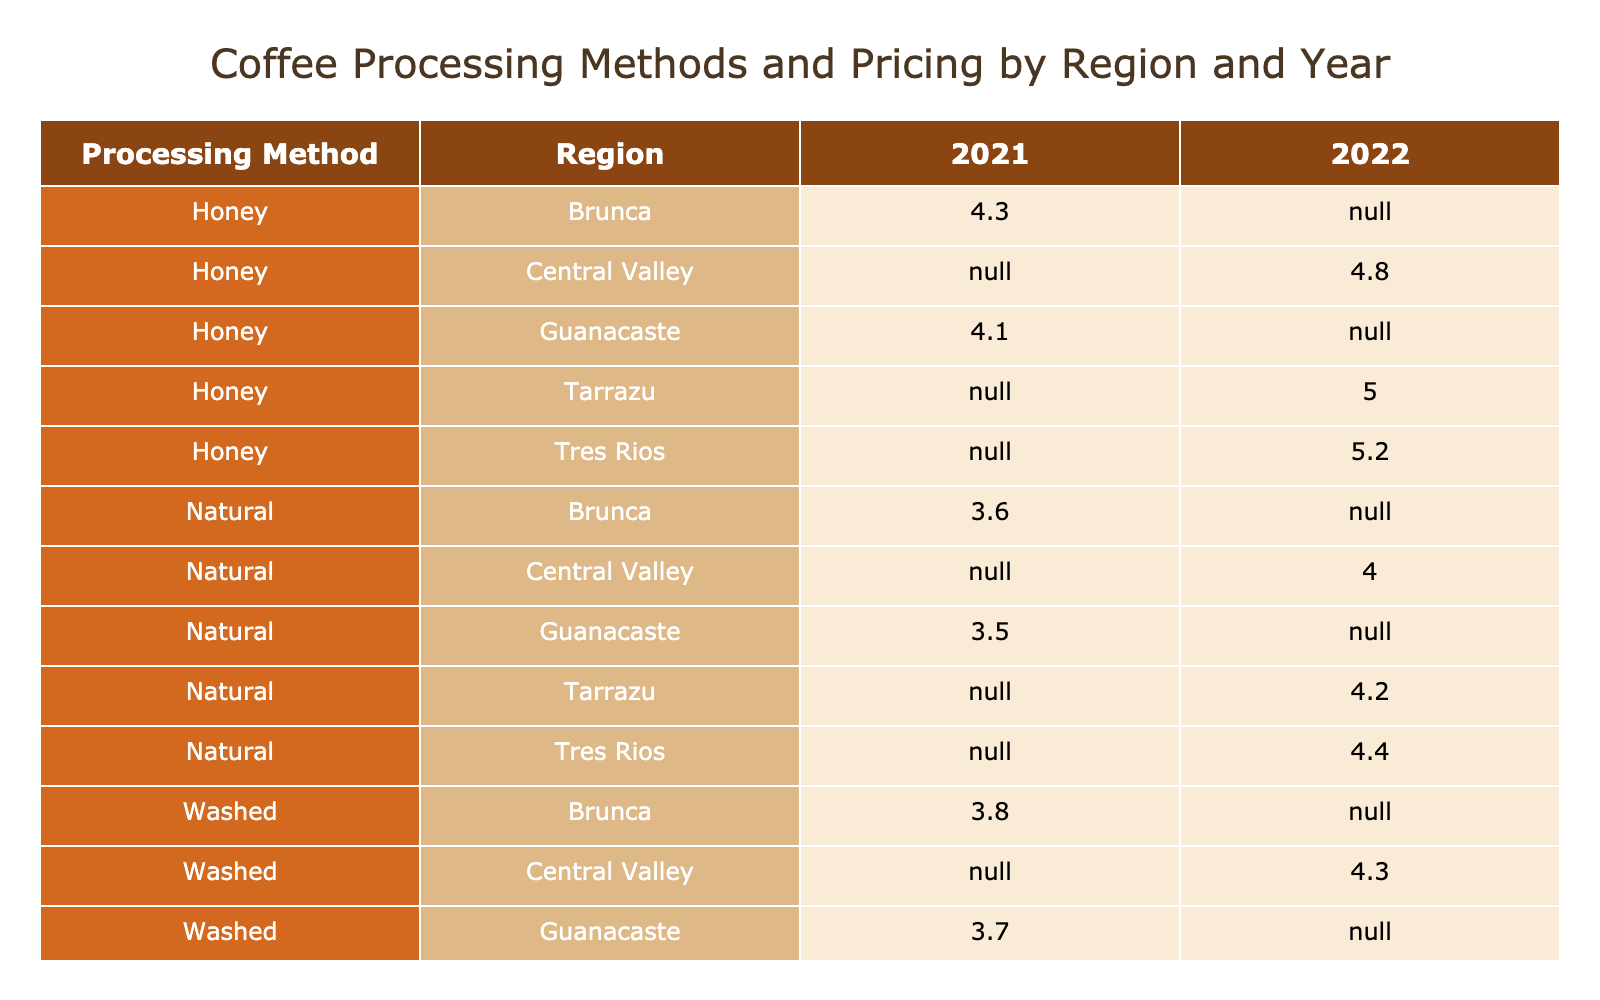What is the price per kg of honey coffee from Tarrazu in 2022? The table shows the price per kg for honey coffee in the Tarrazu region for the harvest year 2022. Looking at the respective cell, it indicates that the price is 5.00.
Answer: 5.00 Which processing method in Brunca had the highest price per kg in 2021? By examining the prices per kg for each processing method in Brunca for the year 2021, we find washed coffee has a price of 3.80, natural coffee is 3.60, and honey coffee is 4.30. Honey coffee has the highest price.
Answer: Honey What is the average price per kg for washed coffee across all regions in 2022? The prices for washed coffee in 2022 are 4.50 (Tarrazu), 4.30 (Central Valley), and 4.70 (Tres Rios). To calculate the average, add these prices (4.50 + 4.30 + 4.70) = 13.50 and then divide by 3 (the number of regions), which results in an average price of 4.50.
Answer: 4.50 Is the price per kg of natural coffee from Guanacaste higher than from Brunca in 2021? Checking the table for natural coffee prices: Guanacaste has a price of 3.50 while Brunca has a price of 3.60. Since 3.50 is not higher than 3.60, the answer is no.
Answer: No What is the total production volume of honey coffee across all regions in 2022? The production volumes for honey coffee in 2022 are 2000 kg (Tarrazu), 2200 kg (Central Valley), and 1900 kg (Tres Rios). Adding these figures gives us a total production volume of 2000 + 2200 + 1900 = 6100 kg.
Answer: 6100 kg Which region produced the most coffee in 2022, and what was the total production volume? For the year 2022, we check the production volumes by region: Tarrazu (5000 kg washed + 3500 kg natural + 2000 kg honey = 10500 kg), Central Valley (5500 kg washed + 4000 kg natural + 2200 kg honey = 11700 kg), and Tres Rios (4800 kg washed + 3200 kg natural + 1900 kg honey = 9900 kg). Thus, Central Valley has the highest total production volume of 11700 kg.
Answer: Central Valley, 11700 kg Are the quality scores for honey coffee consistently higher than washed coffee across all regions in 2021? By examining the quality scores in 2021: For Brunca, honey scored 85 while washed scored 83; for Guanacaste, honey scored 84 while washed scored 82. In both cases, honey coffee has a higher quality score. Therefore, the statement holds true.
Answer: Yes What is the difference in price per kg between washed and natural coffee for the Central Valley in 2022? The price per kg for washed coffee in the Central Valley is 4.30, and for natural coffee, it is 4.00. To find the difference, subtract the price of natural from washed (4.30 - 4.00), resulting in a difference of 0.30.
Answer: 0.30 